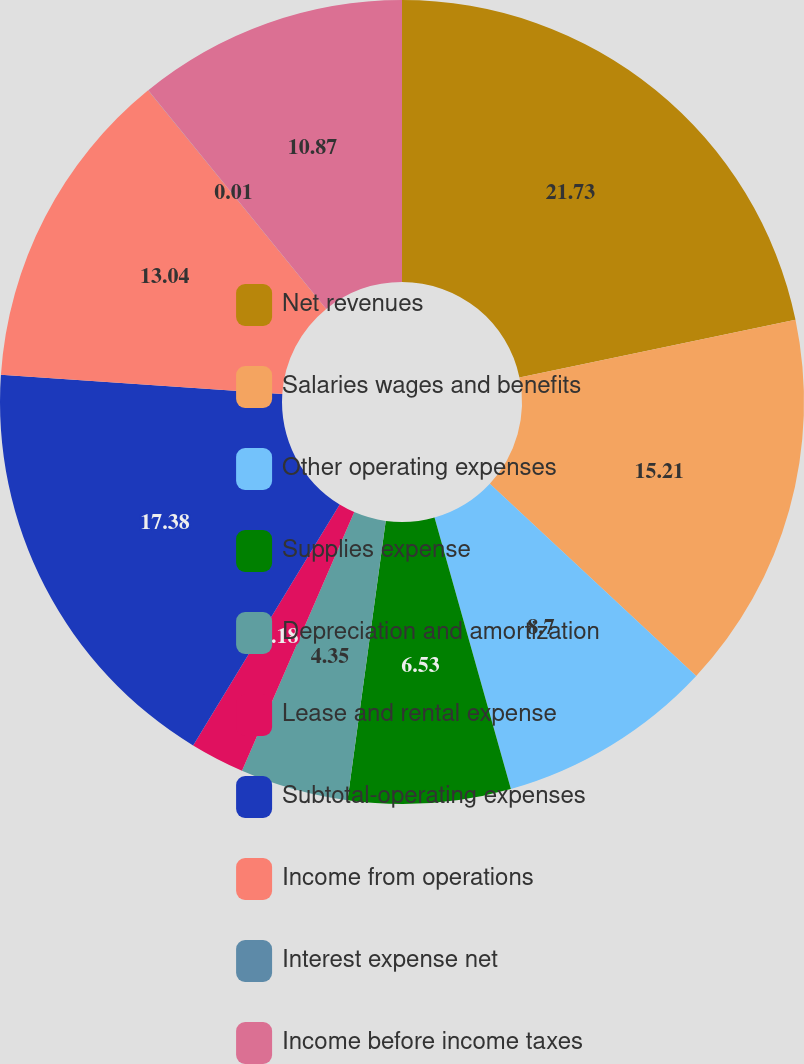Convert chart to OTSL. <chart><loc_0><loc_0><loc_500><loc_500><pie_chart><fcel>Net revenues<fcel>Salaries wages and benefits<fcel>Other operating expenses<fcel>Supplies expense<fcel>Depreciation and amortization<fcel>Lease and rental expense<fcel>Subtotal-operating expenses<fcel>Income from operations<fcel>Interest expense net<fcel>Income before income taxes<nl><fcel>21.72%<fcel>15.21%<fcel>8.7%<fcel>6.53%<fcel>4.35%<fcel>2.18%<fcel>17.38%<fcel>13.04%<fcel>0.01%<fcel>10.87%<nl></chart> 